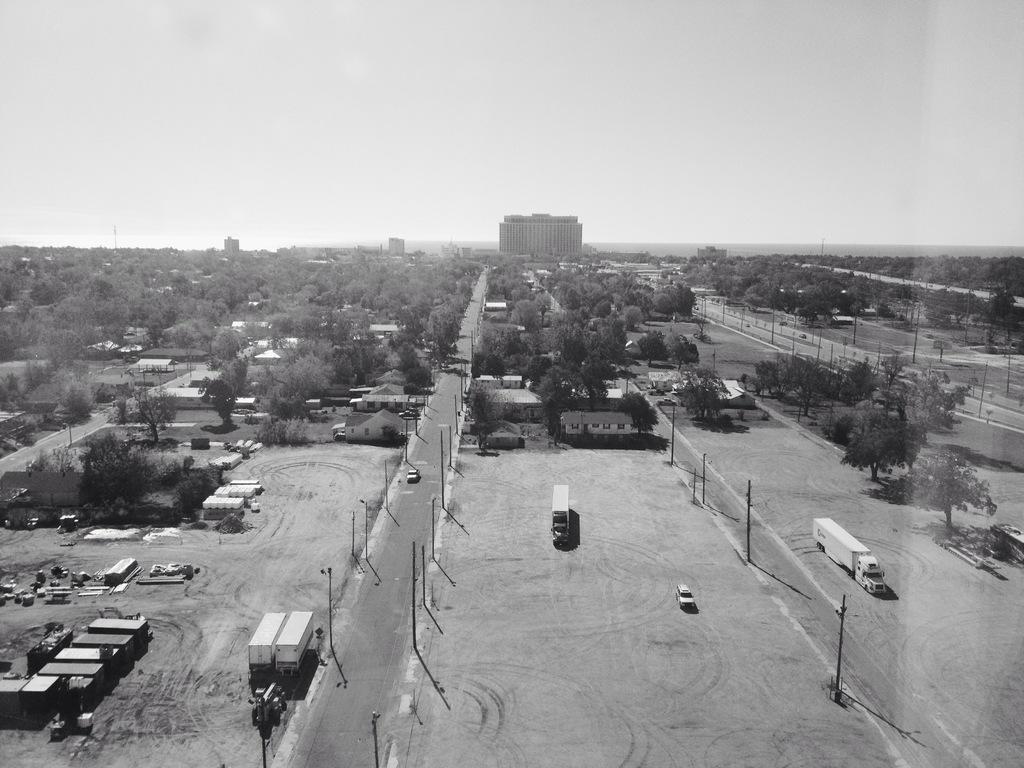Describe this image in one or two sentences. This picture is a black and white image. This picture shows an aerial view of a city. There are some buildings, some houses, some roads, some vehicles, some objects with poles, some poles, some objects on the ground, some trees, plants and bushes on the ground. At the top there is the sky. 